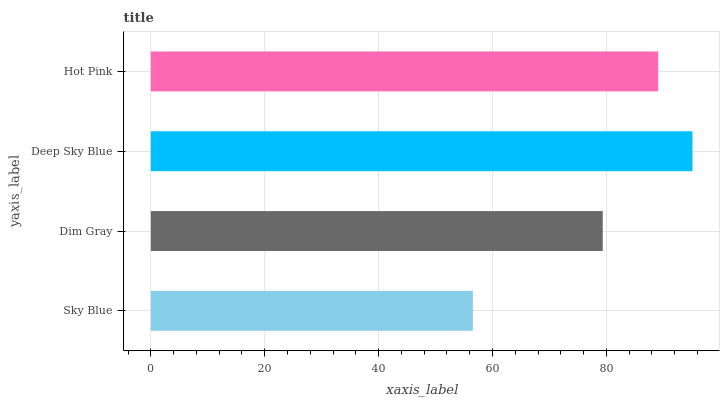Is Sky Blue the minimum?
Answer yes or no. Yes. Is Deep Sky Blue the maximum?
Answer yes or no. Yes. Is Dim Gray the minimum?
Answer yes or no. No. Is Dim Gray the maximum?
Answer yes or no. No. Is Dim Gray greater than Sky Blue?
Answer yes or no. Yes. Is Sky Blue less than Dim Gray?
Answer yes or no. Yes. Is Sky Blue greater than Dim Gray?
Answer yes or no. No. Is Dim Gray less than Sky Blue?
Answer yes or no. No. Is Hot Pink the high median?
Answer yes or no. Yes. Is Dim Gray the low median?
Answer yes or no. Yes. Is Sky Blue the high median?
Answer yes or no. No. Is Deep Sky Blue the low median?
Answer yes or no. No. 